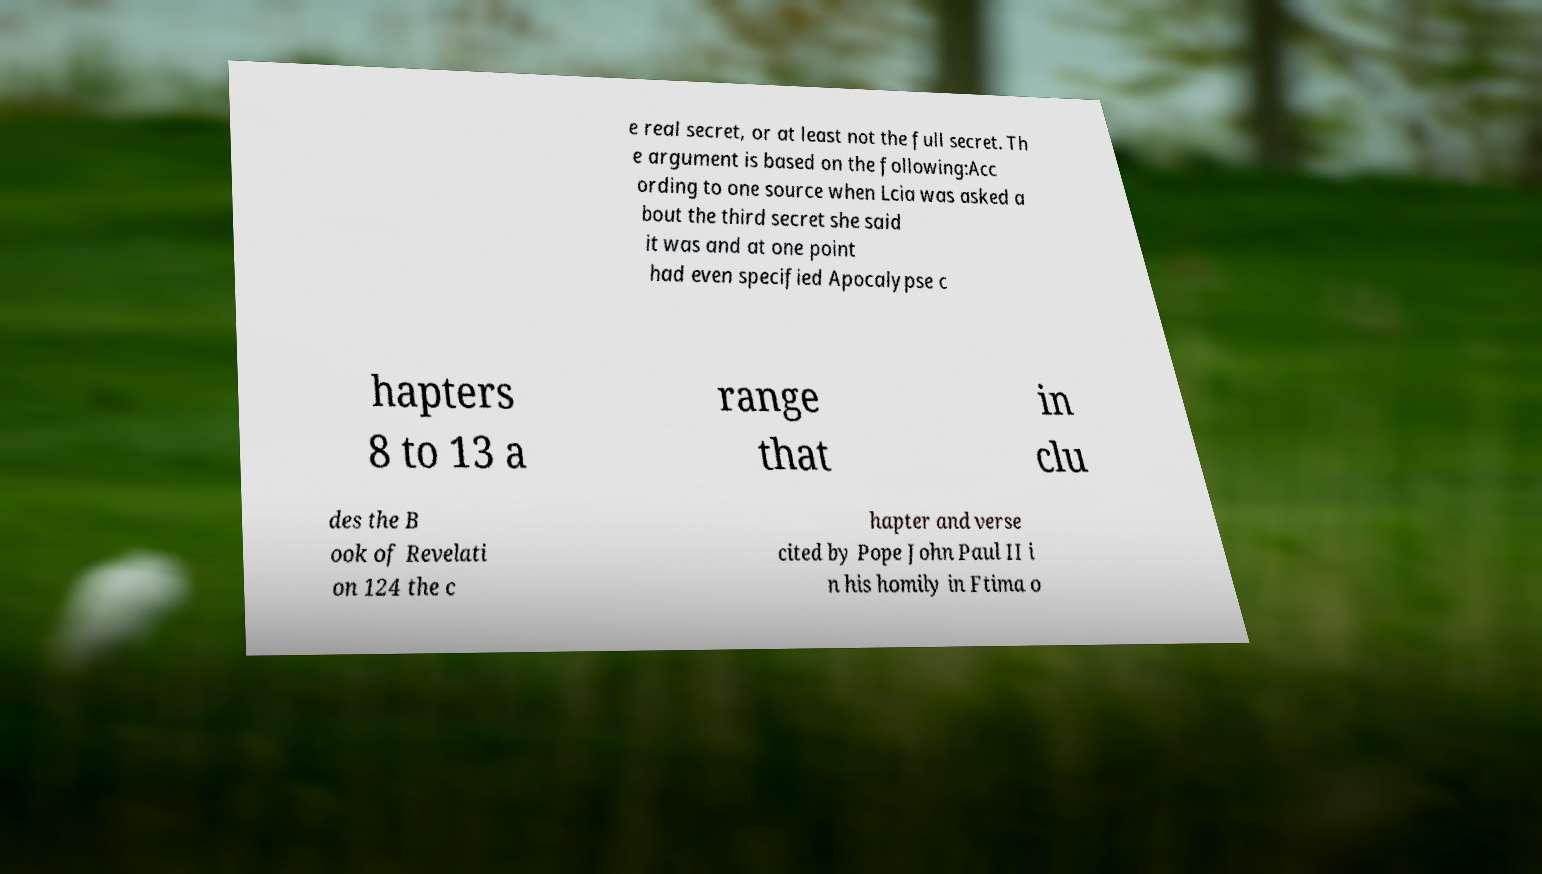I need the written content from this picture converted into text. Can you do that? e real secret, or at least not the full secret. Th e argument is based on the following:Acc ording to one source when Lcia was asked a bout the third secret she said it was and at one point had even specified Apocalypse c hapters 8 to 13 a range that in clu des the B ook of Revelati on 124 the c hapter and verse cited by Pope John Paul II i n his homily in Ftima o 